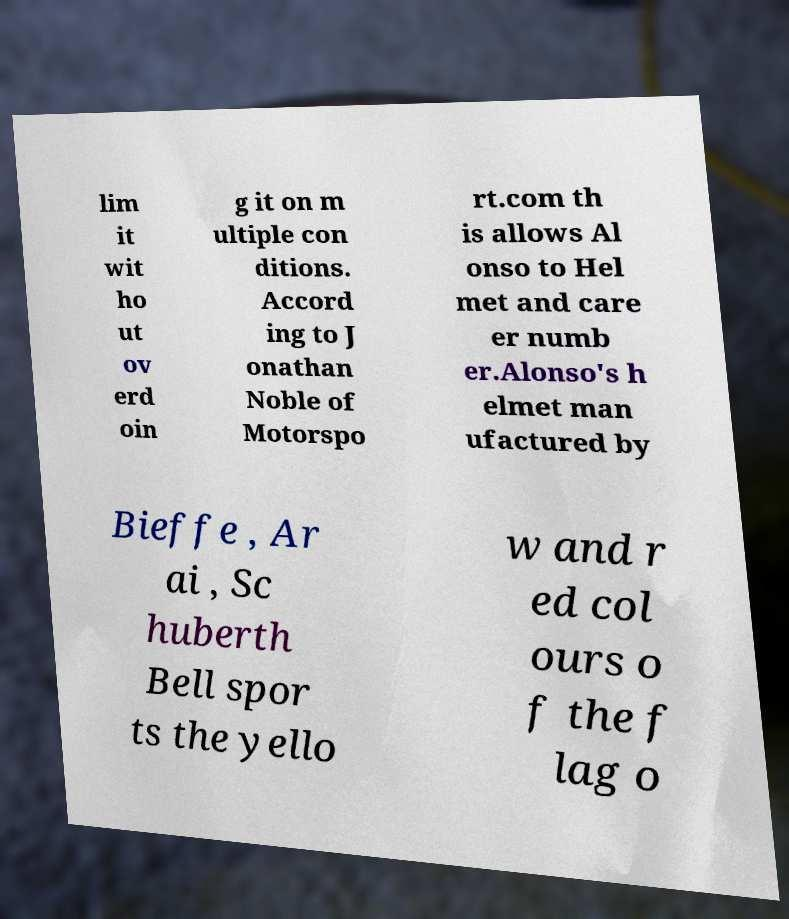For documentation purposes, I need the text within this image transcribed. Could you provide that? lim it wit ho ut ov erd oin g it on m ultiple con ditions. Accord ing to J onathan Noble of Motorspo rt.com th is allows Al onso to Hel met and care er numb er.Alonso's h elmet man ufactured by Bieffe , Ar ai , Sc huberth Bell spor ts the yello w and r ed col ours o f the f lag o 